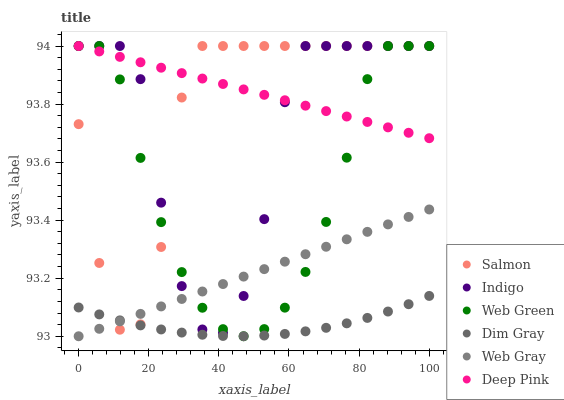Does Dim Gray have the minimum area under the curve?
Answer yes or no. Yes. Does Deep Pink have the maximum area under the curve?
Answer yes or no. Yes. Does Indigo have the minimum area under the curve?
Answer yes or no. No. Does Indigo have the maximum area under the curve?
Answer yes or no. No. Is Deep Pink the smoothest?
Answer yes or no. Yes. Is Indigo the roughest?
Answer yes or no. Yes. Is Indigo the smoothest?
Answer yes or no. No. Is Deep Pink the roughest?
Answer yes or no. No. Does Web Gray have the lowest value?
Answer yes or no. Yes. Does Indigo have the lowest value?
Answer yes or no. No. Does Web Green have the highest value?
Answer yes or no. Yes. Does Dim Gray have the highest value?
Answer yes or no. No. Is Web Gray less than Deep Pink?
Answer yes or no. Yes. Is Deep Pink greater than Web Gray?
Answer yes or no. Yes. Does Web Gray intersect Web Green?
Answer yes or no. Yes. Is Web Gray less than Web Green?
Answer yes or no. No. Is Web Gray greater than Web Green?
Answer yes or no. No. Does Web Gray intersect Deep Pink?
Answer yes or no. No. 